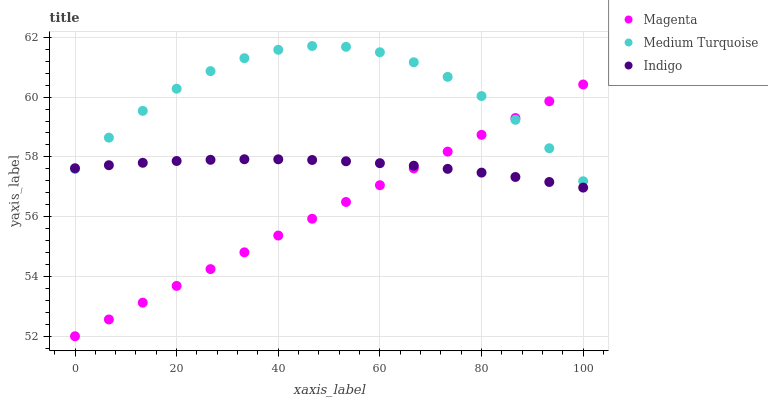Does Magenta have the minimum area under the curve?
Answer yes or no. Yes. Does Medium Turquoise have the maximum area under the curve?
Answer yes or no. Yes. Does Indigo have the minimum area under the curve?
Answer yes or no. No. Does Indigo have the maximum area under the curve?
Answer yes or no. No. Is Magenta the smoothest?
Answer yes or no. Yes. Is Medium Turquoise the roughest?
Answer yes or no. Yes. Is Indigo the smoothest?
Answer yes or no. No. Is Indigo the roughest?
Answer yes or no. No. Does Magenta have the lowest value?
Answer yes or no. Yes. Does Indigo have the lowest value?
Answer yes or no. No. Does Medium Turquoise have the highest value?
Answer yes or no. Yes. Does Indigo have the highest value?
Answer yes or no. No. Does Magenta intersect Indigo?
Answer yes or no. Yes. Is Magenta less than Indigo?
Answer yes or no. No. Is Magenta greater than Indigo?
Answer yes or no. No. 